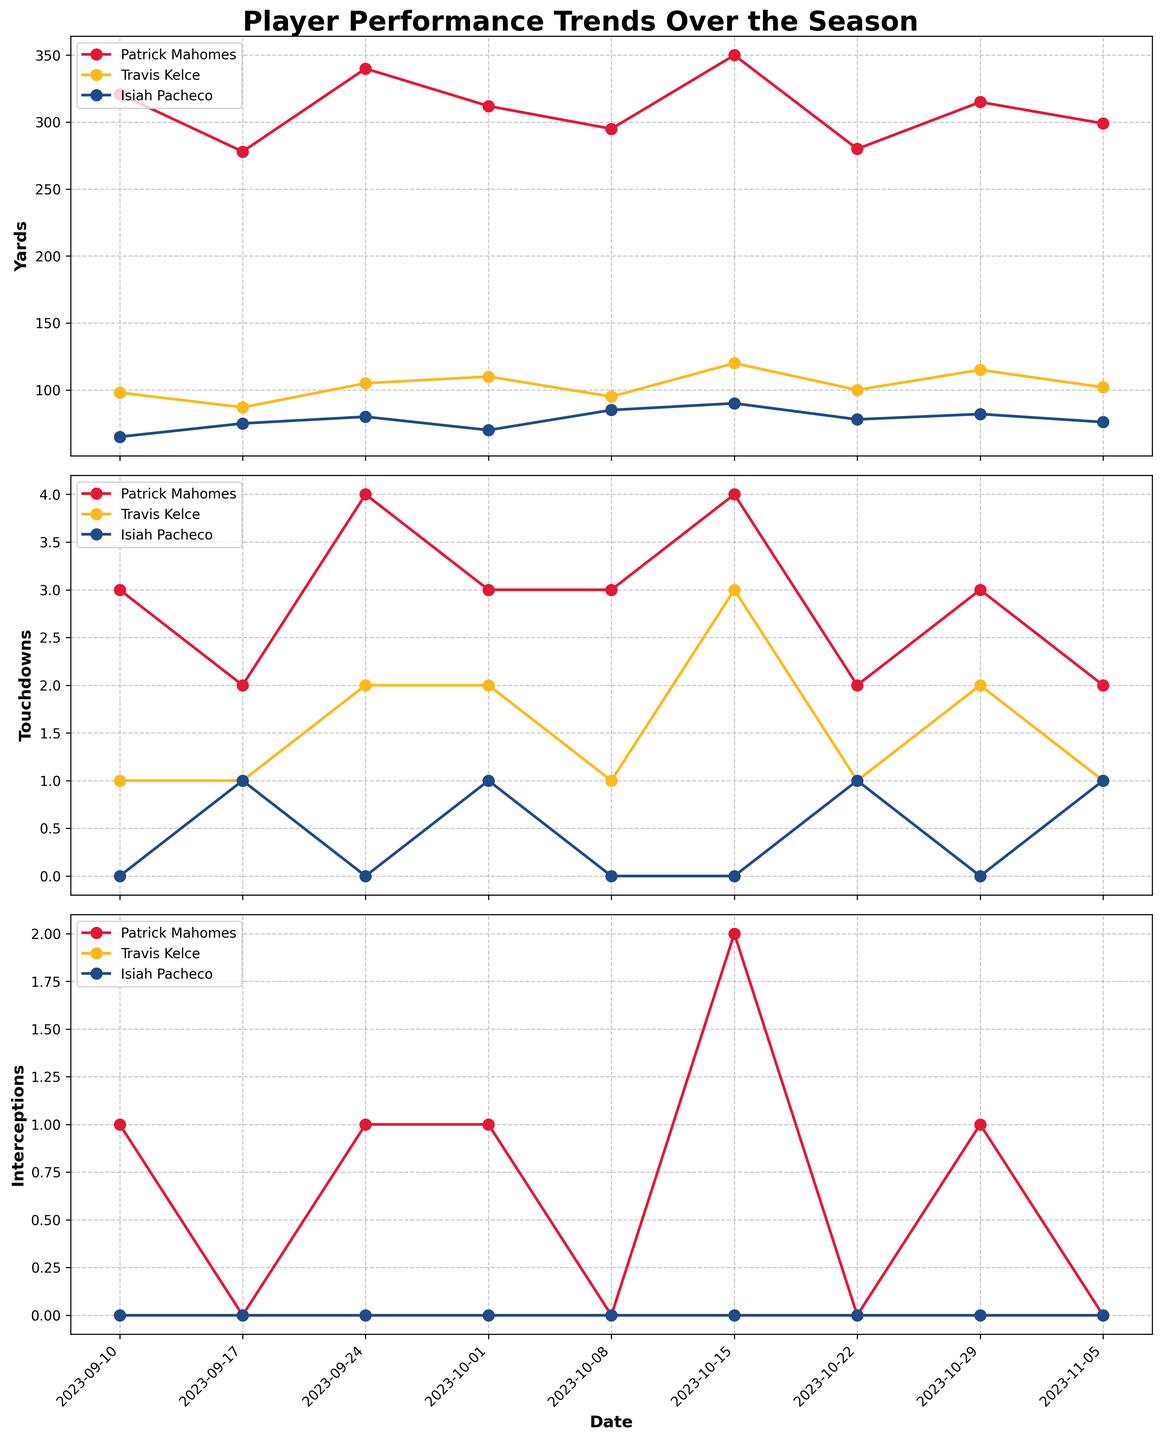What's the title of the figure? The title is located at the top of the figure, typically in bold and larger font size, making it easy to identify. This title provides a general idea about the content of the figure, which helps in understanding the context.
Answer: Player Performance Trends Over the Season How many players are represented in the figure? By observing the legends in each subplot, one can see the names of the players mentioned. Counting these names gives the number of players represented in the figure.
Answer: 3 Which player has the highest number of touchdowns on October 15, 2023? Look for the data points corresponding to October 15, 2023, in the plot for touchdowns. Identify the player with the highest value on that date.
Answer: Travis Kelce What is the trend of Patrick Mahomes' interceptions over the season? Assess the plot for interceptions, focusing on the line corresponding to Patrick Mahomes (identified by color or legend). Observe whether the line is mostly increasing, decreasing, or fluctuating.
Answer: Fluctuating Who had the maximum yards on September 24, 2023? Check the data points for September 24, 2023, in the plot for yards. Compare the values for each player on that date to identify who had the highest yards.
Answer: Patrick Mahomes Which player consistently has zero interceptions throughout the season? Examine the interceptions plot for any player whose data points are always at zero across all dates.
Answer: Travis Kelce How does Isiah Pacheco's touchdown performance compare between October 1 and October 22, 2023? Look at the touchdowns plot and find Isiah Pacheco's values on October 1 and October 22, 2023. Compare the two values to determine whether his performance improved, declined, or remained constant.
Answer: Improved What is the average number of touchdowns for Patrick Mahomes over the first three games? Find Patrick Mahomes' touchdowns for the first three games (September 10, 17, and 24) and calculate their average by summing these values and dividing by 3.
Answer: 3 Did Travis Kelce have a peak in yard performance? If so, when? Observe the yards plot for Travis Kelce and identify the highest data point (peak). Note the corresponding date to find when this peak occurred.
Answer: October 15, 2023 Compare the touchdown performance of Travis Kelce and Isiah Pacheco on October 29, 2023. Who performed better? Look at the touchdowns plot and compare the values for Travis Kelce and Isiah Pacheco on October 29, 2023. Identify who had the higher value.
Answer: Travis Kelce 